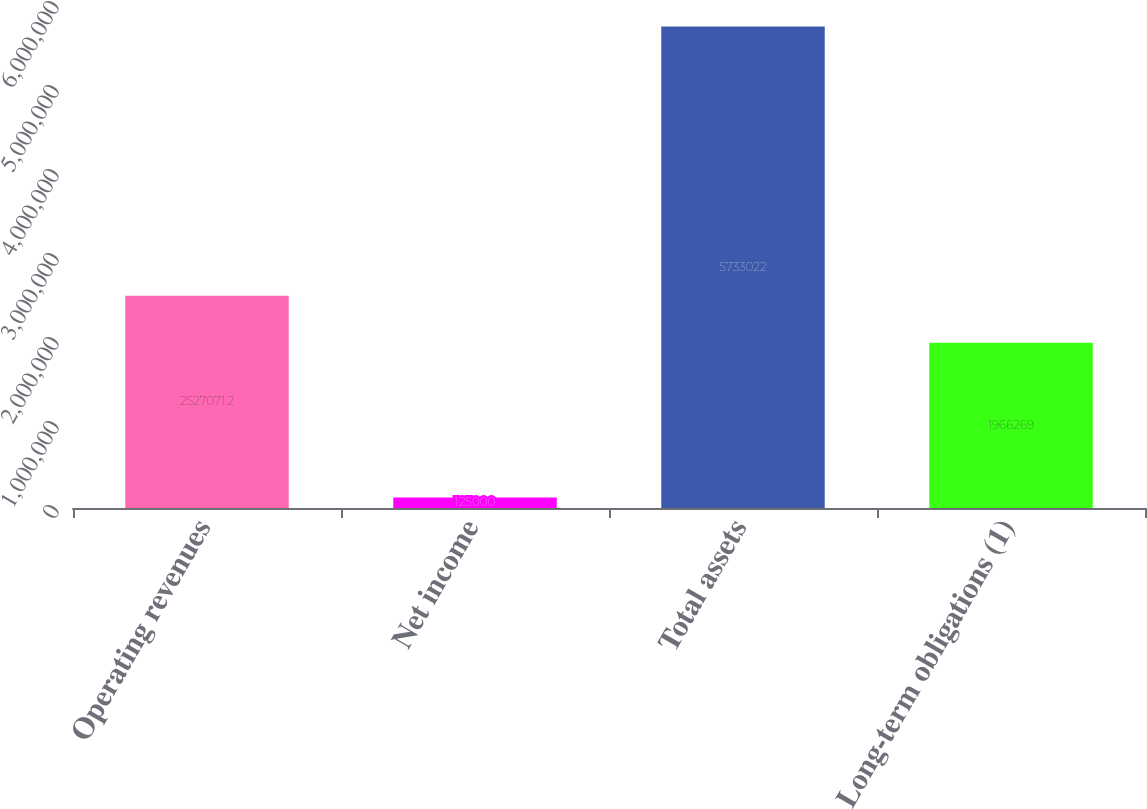Convert chart to OTSL. <chart><loc_0><loc_0><loc_500><loc_500><bar_chart><fcel>Operating revenues<fcel>Net income<fcel>Total assets<fcel>Long-term obligations (1)<nl><fcel>2.52707e+06<fcel>125000<fcel>5.73302e+06<fcel>1.96627e+06<nl></chart> 